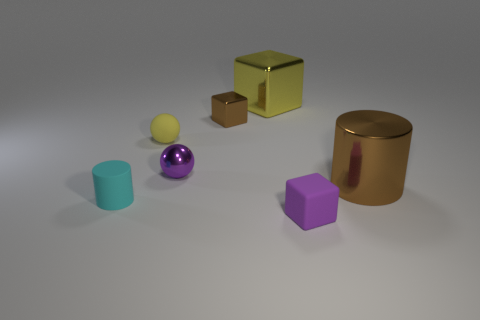Can you describe the texture and material of the objects presented? Certainly! The objects seem to have different textures and materials. The cyan cup and the purple cube have a matte finish suggesting they might be made of rubber or a matte plastic. The gold cylinder and block appear to have a reflective surface, indicative of a metallic material. And the small yellow sphere has a slightly muted shine, which could suggest it's either a coated metal or a hard plastic. 